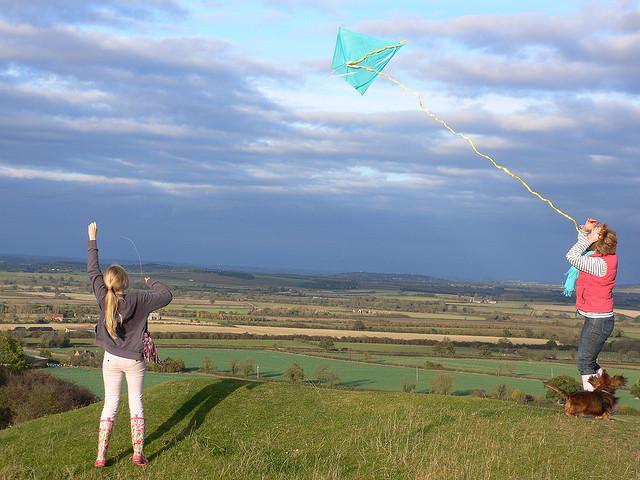What is the woman doing?
Be succinct. Flying kite. Is the wind blowing?
Be succinct. Yes. What colors are in the kite?
Keep it brief. Blue and white. What color is the kite?
Be succinct. Blue. Are the women in an urban environment?
Short answer required. No. 